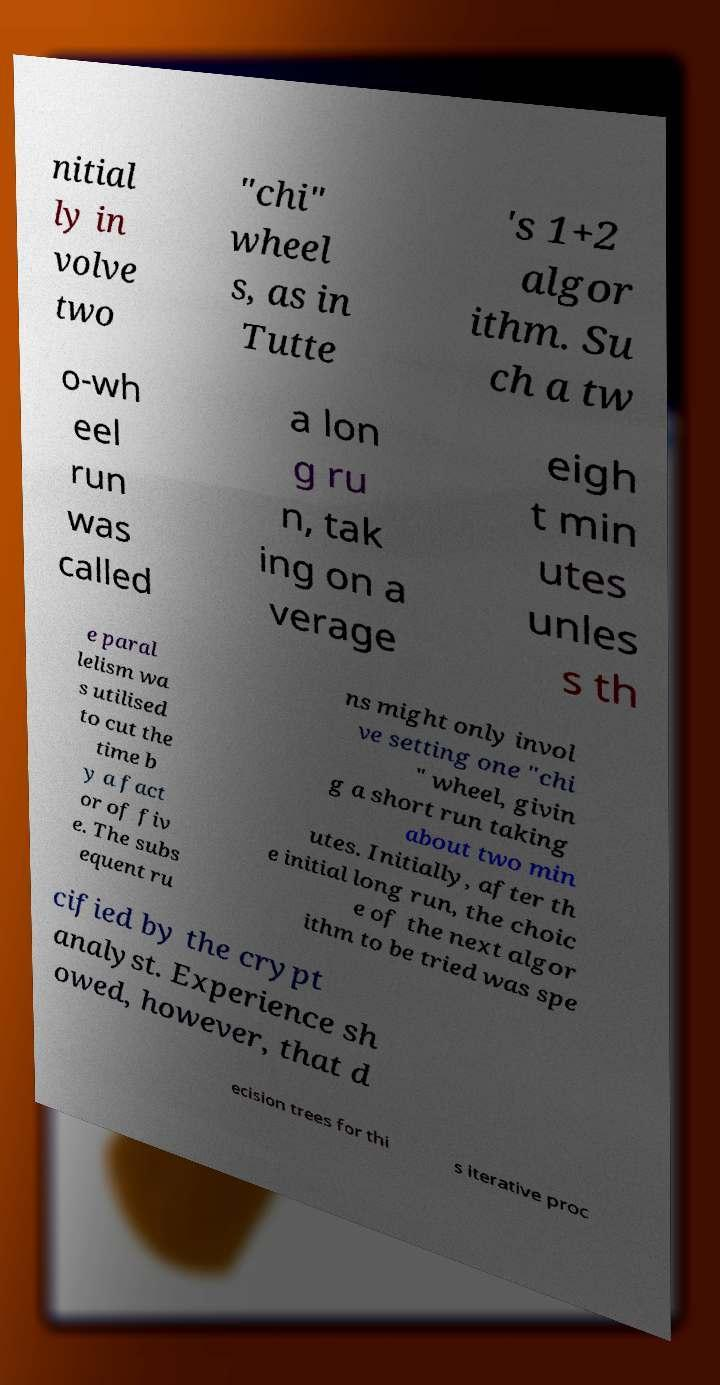Can you accurately transcribe the text from the provided image for me? nitial ly in volve two "chi" wheel s, as in Tutte 's 1+2 algor ithm. Su ch a tw o-wh eel run was called a lon g ru n, tak ing on a verage eigh t min utes unles s th e paral lelism wa s utilised to cut the time b y a fact or of fiv e. The subs equent ru ns might only invol ve setting one "chi " wheel, givin g a short run taking about two min utes. Initially, after th e initial long run, the choic e of the next algor ithm to be tried was spe cified by the crypt analyst. Experience sh owed, however, that d ecision trees for thi s iterative proc 